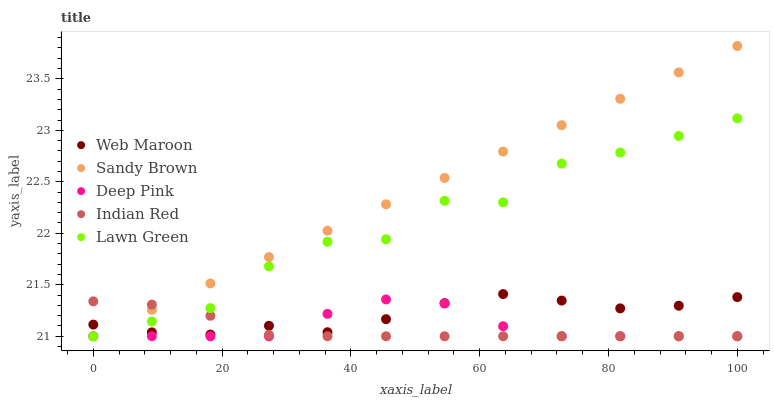Does Indian Red have the minimum area under the curve?
Answer yes or no. Yes. Does Sandy Brown have the maximum area under the curve?
Answer yes or no. Yes. Does Deep Pink have the minimum area under the curve?
Answer yes or no. No. Does Deep Pink have the maximum area under the curve?
Answer yes or no. No. Is Sandy Brown the smoothest?
Answer yes or no. Yes. Is Lawn Green the roughest?
Answer yes or no. Yes. Is Deep Pink the smoothest?
Answer yes or no. No. Is Deep Pink the roughest?
Answer yes or no. No. Does Sandy Brown have the lowest value?
Answer yes or no. Yes. Does Web Maroon have the lowest value?
Answer yes or no. No. Does Sandy Brown have the highest value?
Answer yes or no. Yes. Does Deep Pink have the highest value?
Answer yes or no. No. Does Web Maroon intersect Lawn Green?
Answer yes or no. Yes. Is Web Maroon less than Lawn Green?
Answer yes or no. No. Is Web Maroon greater than Lawn Green?
Answer yes or no. No. 